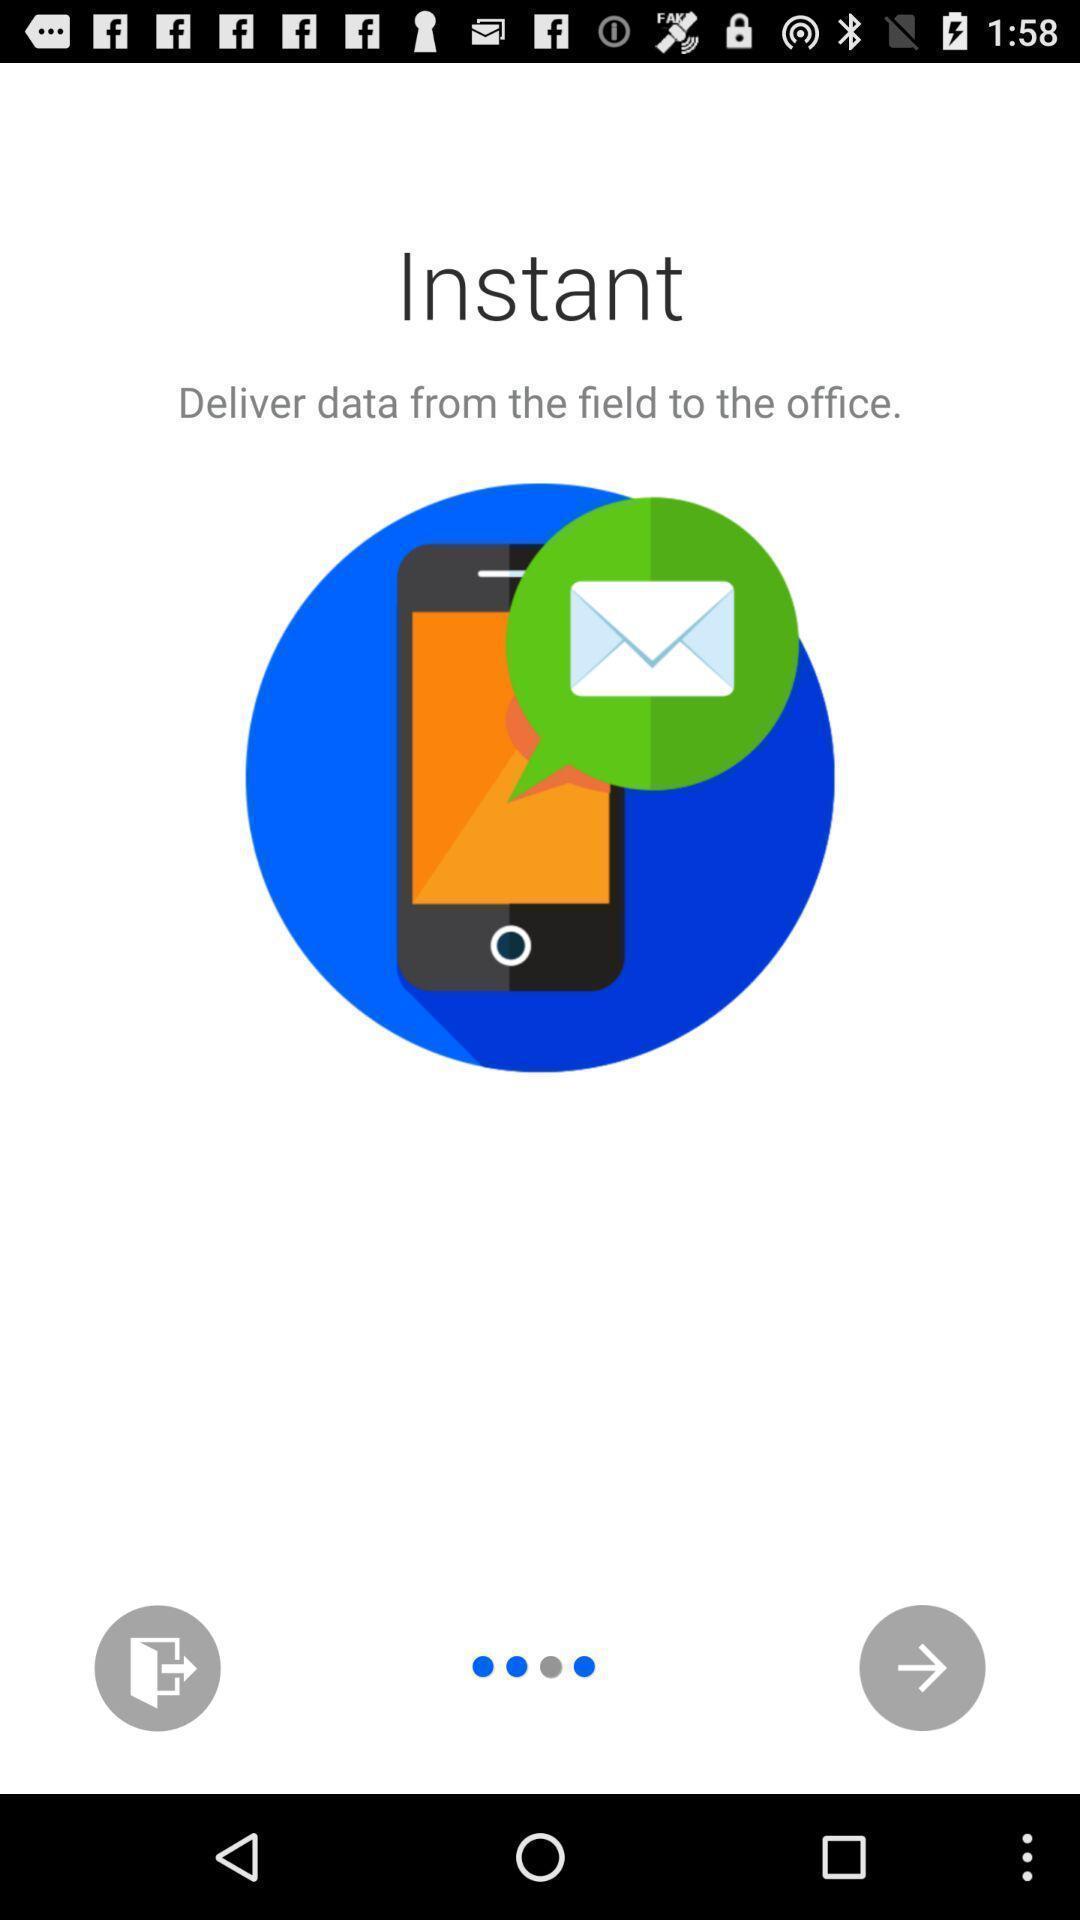Please provide a description for this image. Welcome page to an app. 